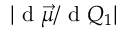Convert formula to latex. <formula><loc_0><loc_0><loc_500><loc_500>| d \vec { \mu } / d Q _ { 1 } |</formula> 